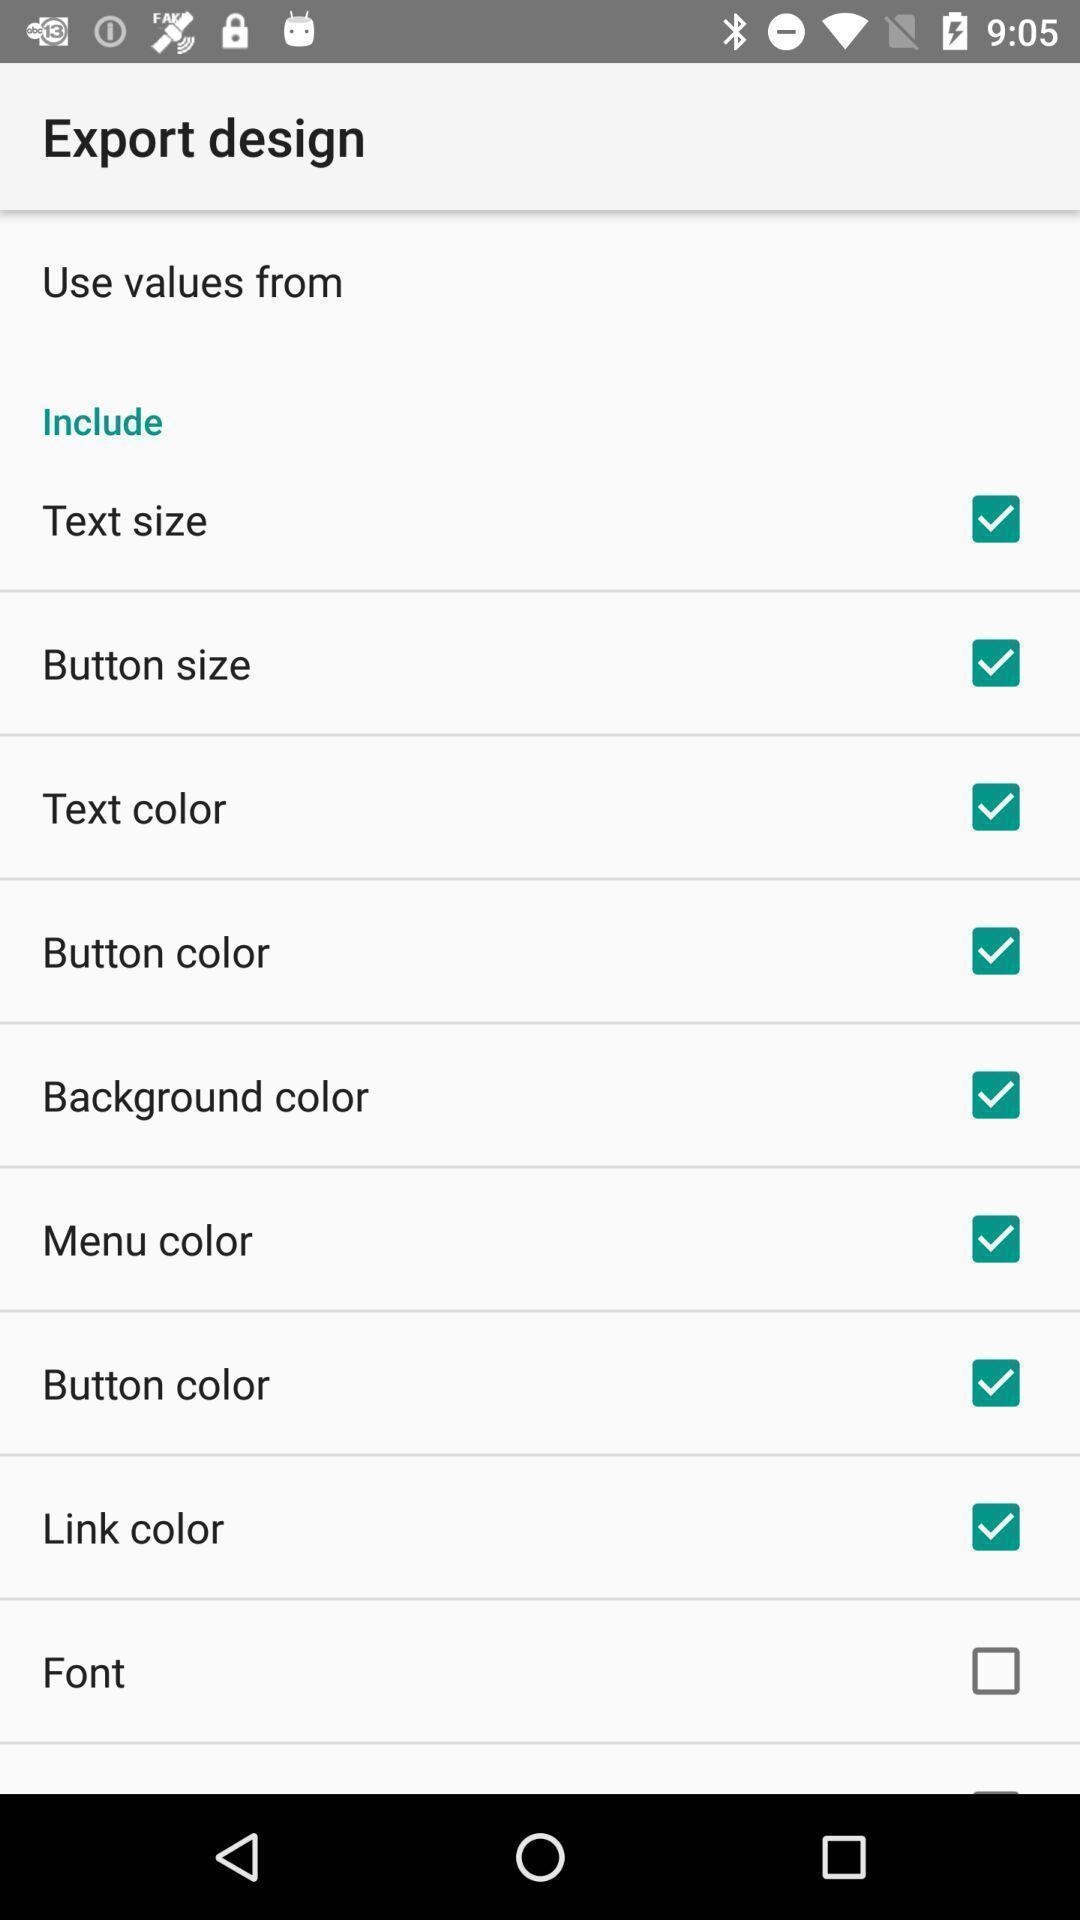Provide a detailed account of this screenshot. Settings page for setting design. 